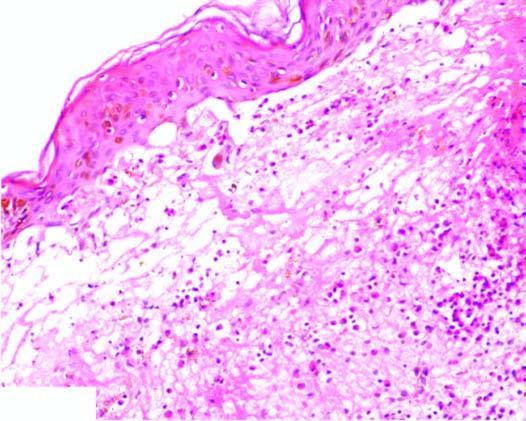do the tips of dermal papillae show neutrophilic microabscess causing dermo-epidermal separation at tips?
Answer the question using a single word or phrase. Yes 